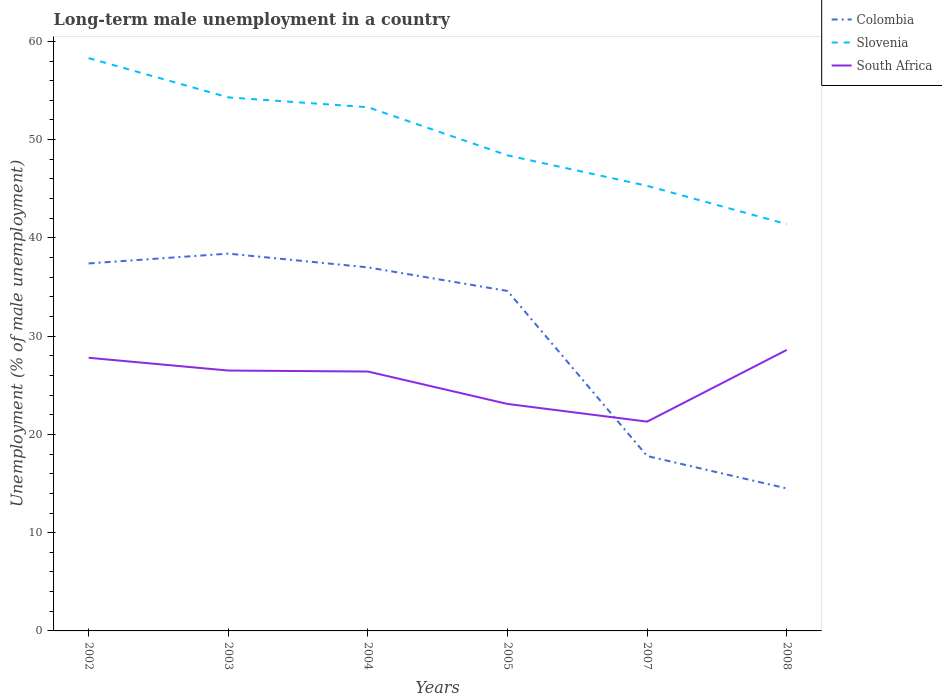Does the line corresponding to Colombia intersect with the line corresponding to Slovenia?
Offer a terse response. No. Is the number of lines equal to the number of legend labels?
Ensure brevity in your answer.  Yes. Across all years, what is the maximum percentage of long-term unemployed male population in Slovenia?
Offer a terse response. 41.4. What is the total percentage of long-term unemployed male population in Slovenia in the graph?
Offer a terse response. 12.9. What is the difference between the highest and the second highest percentage of long-term unemployed male population in Colombia?
Provide a short and direct response. 23.9. How many lines are there?
Provide a short and direct response. 3. How many years are there in the graph?
Keep it short and to the point. 6. What is the difference between two consecutive major ticks on the Y-axis?
Offer a terse response. 10. Does the graph contain any zero values?
Offer a very short reply. No. Does the graph contain grids?
Make the answer very short. No. Where does the legend appear in the graph?
Provide a succinct answer. Top right. How many legend labels are there?
Make the answer very short. 3. How are the legend labels stacked?
Your response must be concise. Vertical. What is the title of the graph?
Give a very brief answer. Long-term male unemployment in a country. Does "Canada" appear as one of the legend labels in the graph?
Give a very brief answer. No. What is the label or title of the Y-axis?
Give a very brief answer. Unemployment (% of male unemployment). What is the Unemployment (% of male unemployment) of Colombia in 2002?
Your answer should be very brief. 37.4. What is the Unemployment (% of male unemployment) in Slovenia in 2002?
Offer a very short reply. 58.3. What is the Unemployment (% of male unemployment) of South Africa in 2002?
Ensure brevity in your answer.  27.8. What is the Unemployment (% of male unemployment) in Colombia in 2003?
Give a very brief answer. 38.4. What is the Unemployment (% of male unemployment) of Slovenia in 2003?
Offer a terse response. 54.3. What is the Unemployment (% of male unemployment) of South Africa in 2003?
Provide a short and direct response. 26.5. What is the Unemployment (% of male unemployment) of Slovenia in 2004?
Your answer should be compact. 53.3. What is the Unemployment (% of male unemployment) of South Africa in 2004?
Make the answer very short. 26.4. What is the Unemployment (% of male unemployment) in Colombia in 2005?
Provide a short and direct response. 34.6. What is the Unemployment (% of male unemployment) of Slovenia in 2005?
Offer a terse response. 48.4. What is the Unemployment (% of male unemployment) of South Africa in 2005?
Provide a succinct answer. 23.1. What is the Unemployment (% of male unemployment) in Colombia in 2007?
Give a very brief answer. 17.8. What is the Unemployment (% of male unemployment) in Slovenia in 2007?
Your answer should be very brief. 45.3. What is the Unemployment (% of male unemployment) in South Africa in 2007?
Provide a short and direct response. 21.3. What is the Unemployment (% of male unemployment) in Slovenia in 2008?
Your answer should be compact. 41.4. What is the Unemployment (% of male unemployment) in South Africa in 2008?
Provide a short and direct response. 28.6. Across all years, what is the maximum Unemployment (% of male unemployment) in Colombia?
Offer a terse response. 38.4. Across all years, what is the maximum Unemployment (% of male unemployment) in Slovenia?
Make the answer very short. 58.3. Across all years, what is the maximum Unemployment (% of male unemployment) of South Africa?
Ensure brevity in your answer.  28.6. Across all years, what is the minimum Unemployment (% of male unemployment) in Colombia?
Provide a succinct answer. 14.5. Across all years, what is the minimum Unemployment (% of male unemployment) of Slovenia?
Make the answer very short. 41.4. Across all years, what is the minimum Unemployment (% of male unemployment) of South Africa?
Provide a short and direct response. 21.3. What is the total Unemployment (% of male unemployment) in Colombia in the graph?
Offer a terse response. 179.7. What is the total Unemployment (% of male unemployment) in Slovenia in the graph?
Make the answer very short. 301. What is the total Unemployment (% of male unemployment) in South Africa in the graph?
Your answer should be very brief. 153.7. What is the difference between the Unemployment (% of male unemployment) of Colombia in 2002 and that in 2003?
Give a very brief answer. -1. What is the difference between the Unemployment (% of male unemployment) of South Africa in 2002 and that in 2003?
Your answer should be very brief. 1.3. What is the difference between the Unemployment (% of male unemployment) in Colombia in 2002 and that in 2004?
Ensure brevity in your answer.  0.4. What is the difference between the Unemployment (% of male unemployment) of South Africa in 2002 and that in 2004?
Make the answer very short. 1.4. What is the difference between the Unemployment (% of male unemployment) in Colombia in 2002 and that in 2005?
Provide a succinct answer. 2.8. What is the difference between the Unemployment (% of male unemployment) of Slovenia in 2002 and that in 2005?
Provide a short and direct response. 9.9. What is the difference between the Unemployment (% of male unemployment) of South Africa in 2002 and that in 2005?
Your answer should be very brief. 4.7. What is the difference between the Unemployment (% of male unemployment) in Colombia in 2002 and that in 2007?
Provide a succinct answer. 19.6. What is the difference between the Unemployment (% of male unemployment) in South Africa in 2002 and that in 2007?
Your answer should be very brief. 6.5. What is the difference between the Unemployment (% of male unemployment) in Colombia in 2002 and that in 2008?
Offer a terse response. 22.9. What is the difference between the Unemployment (% of male unemployment) of Slovenia in 2002 and that in 2008?
Give a very brief answer. 16.9. What is the difference between the Unemployment (% of male unemployment) in South Africa in 2003 and that in 2004?
Make the answer very short. 0.1. What is the difference between the Unemployment (% of male unemployment) in Colombia in 2003 and that in 2005?
Give a very brief answer. 3.8. What is the difference between the Unemployment (% of male unemployment) of Slovenia in 2003 and that in 2005?
Ensure brevity in your answer.  5.9. What is the difference between the Unemployment (% of male unemployment) in South Africa in 2003 and that in 2005?
Ensure brevity in your answer.  3.4. What is the difference between the Unemployment (% of male unemployment) in Colombia in 2003 and that in 2007?
Offer a terse response. 20.6. What is the difference between the Unemployment (% of male unemployment) of Colombia in 2003 and that in 2008?
Provide a succinct answer. 23.9. What is the difference between the Unemployment (% of male unemployment) in Slovenia in 2003 and that in 2008?
Keep it short and to the point. 12.9. What is the difference between the Unemployment (% of male unemployment) of South Africa in 2003 and that in 2008?
Keep it short and to the point. -2.1. What is the difference between the Unemployment (% of male unemployment) of Slovenia in 2004 and that in 2005?
Keep it short and to the point. 4.9. What is the difference between the Unemployment (% of male unemployment) in South Africa in 2004 and that in 2005?
Offer a terse response. 3.3. What is the difference between the Unemployment (% of male unemployment) in Colombia in 2004 and that in 2007?
Provide a short and direct response. 19.2. What is the difference between the Unemployment (% of male unemployment) of Colombia in 2004 and that in 2008?
Your answer should be very brief. 22.5. What is the difference between the Unemployment (% of male unemployment) in Slovenia in 2004 and that in 2008?
Your answer should be very brief. 11.9. What is the difference between the Unemployment (% of male unemployment) in South Africa in 2004 and that in 2008?
Make the answer very short. -2.2. What is the difference between the Unemployment (% of male unemployment) of Colombia in 2005 and that in 2007?
Ensure brevity in your answer.  16.8. What is the difference between the Unemployment (% of male unemployment) in Slovenia in 2005 and that in 2007?
Provide a succinct answer. 3.1. What is the difference between the Unemployment (% of male unemployment) in Colombia in 2005 and that in 2008?
Make the answer very short. 20.1. What is the difference between the Unemployment (% of male unemployment) of Slovenia in 2005 and that in 2008?
Your answer should be compact. 7. What is the difference between the Unemployment (% of male unemployment) of South Africa in 2005 and that in 2008?
Your answer should be compact. -5.5. What is the difference between the Unemployment (% of male unemployment) of Colombia in 2002 and the Unemployment (% of male unemployment) of Slovenia in 2003?
Make the answer very short. -16.9. What is the difference between the Unemployment (% of male unemployment) in Colombia in 2002 and the Unemployment (% of male unemployment) in South Africa in 2003?
Give a very brief answer. 10.9. What is the difference between the Unemployment (% of male unemployment) in Slovenia in 2002 and the Unemployment (% of male unemployment) in South Africa in 2003?
Ensure brevity in your answer.  31.8. What is the difference between the Unemployment (% of male unemployment) of Colombia in 2002 and the Unemployment (% of male unemployment) of Slovenia in 2004?
Offer a very short reply. -15.9. What is the difference between the Unemployment (% of male unemployment) of Colombia in 2002 and the Unemployment (% of male unemployment) of South Africa in 2004?
Give a very brief answer. 11. What is the difference between the Unemployment (% of male unemployment) of Slovenia in 2002 and the Unemployment (% of male unemployment) of South Africa in 2004?
Offer a very short reply. 31.9. What is the difference between the Unemployment (% of male unemployment) of Colombia in 2002 and the Unemployment (% of male unemployment) of Slovenia in 2005?
Ensure brevity in your answer.  -11. What is the difference between the Unemployment (% of male unemployment) of Colombia in 2002 and the Unemployment (% of male unemployment) of South Africa in 2005?
Your answer should be compact. 14.3. What is the difference between the Unemployment (% of male unemployment) in Slovenia in 2002 and the Unemployment (% of male unemployment) in South Africa in 2005?
Ensure brevity in your answer.  35.2. What is the difference between the Unemployment (% of male unemployment) of Colombia in 2002 and the Unemployment (% of male unemployment) of South Africa in 2007?
Make the answer very short. 16.1. What is the difference between the Unemployment (% of male unemployment) of Slovenia in 2002 and the Unemployment (% of male unemployment) of South Africa in 2007?
Make the answer very short. 37. What is the difference between the Unemployment (% of male unemployment) of Slovenia in 2002 and the Unemployment (% of male unemployment) of South Africa in 2008?
Offer a terse response. 29.7. What is the difference between the Unemployment (% of male unemployment) in Colombia in 2003 and the Unemployment (% of male unemployment) in Slovenia in 2004?
Ensure brevity in your answer.  -14.9. What is the difference between the Unemployment (% of male unemployment) in Colombia in 2003 and the Unemployment (% of male unemployment) in South Africa in 2004?
Provide a short and direct response. 12. What is the difference between the Unemployment (% of male unemployment) of Slovenia in 2003 and the Unemployment (% of male unemployment) of South Africa in 2004?
Your response must be concise. 27.9. What is the difference between the Unemployment (% of male unemployment) of Colombia in 2003 and the Unemployment (% of male unemployment) of Slovenia in 2005?
Keep it short and to the point. -10. What is the difference between the Unemployment (% of male unemployment) of Slovenia in 2003 and the Unemployment (% of male unemployment) of South Africa in 2005?
Your response must be concise. 31.2. What is the difference between the Unemployment (% of male unemployment) in Colombia in 2003 and the Unemployment (% of male unemployment) in South Africa in 2007?
Keep it short and to the point. 17.1. What is the difference between the Unemployment (% of male unemployment) of Colombia in 2003 and the Unemployment (% of male unemployment) of Slovenia in 2008?
Give a very brief answer. -3. What is the difference between the Unemployment (% of male unemployment) in Slovenia in 2003 and the Unemployment (% of male unemployment) in South Africa in 2008?
Give a very brief answer. 25.7. What is the difference between the Unemployment (% of male unemployment) in Colombia in 2004 and the Unemployment (% of male unemployment) in Slovenia in 2005?
Offer a very short reply. -11.4. What is the difference between the Unemployment (% of male unemployment) in Colombia in 2004 and the Unemployment (% of male unemployment) in South Africa in 2005?
Offer a very short reply. 13.9. What is the difference between the Unemployment (% of male unemployment) of Slovenia in 2004 and the Unemployment (% of male unemployment) of South Africa in 2005?
Offer a very short reply. 30.2. What is the difference between the Unemployment (% of male unemployment) in Colombia in 2004 and the Unemployment (% of male unemployment) in South Africa in 2007?
Make the answer very short. 15.7. What is the difference between the Unemployment (% of male unemployment) of Slovenia in 2004 and the Unemployment (% of male unemployment) of South Africa in 2008?
Your answer should be very brief. 24.7. What is the difference between the Unemployment (% of male unemployment) of Colombia in 2005 and the Unemployment (% of male unemployment) of South Africa in 2007?
Offer a very short reply. 13.3. What is the difference between the Unemployment (% of male unemployment) in Slovenia in 2005 and the Unemployment (% of male unemployment) in South Africa in 2007?
Provide a succinct answer. 27.1. What is the difference between the Unemployment (% of male unemployment) of Colombia in 2005 and the Unemployment (% of male unemployment) of Slovenia in 2008?
Your answer should be very brief. -6.8. What is the difference between the Unemployment (% of male unemployment) in Slovenia in 2005 and the Unemployment (% of male unemployment) in South Africa in 2008?
Give a very brief answer. 19.8. What is the difference between the Unemployment (% of male unemployment) in Colombia in 2007 and the Unemployment (% of male unemployment) in Slovenia in 2008?
Provide a short and direct response. -23.6. What is the difference between the Unemployment (% of male unemployment) of Slovenia in 2007 and the Unemployment (% of male unemployment) of South Africa in 2008?
Offer a very short reply. 16.7. What is the average Unemployment (% of male unemployment) in Colombia per year?
Offer a very short reply. 29.95. What is the average Unemployment (% of male unemployment) in Slovenia per year?
Your response must be concise. 50.17. What is the average Unemployment (% of male unemployment) of South Africa per year?
Your answer should be very brief. 25.62. In the year 2002, what is the difference between the Unemployment (% of male unemployment) in Colombia and Unemployment (% of male unemployment) in Slovenia?
Your answer should be compact. -20.9. In the year 2002, what is the difference between the Unemployment (% of male unemployment) of Colombia and Unemployment (% of male unemployment) of South Africa?
Provide a succinct answer. 9.6. In the year 2002, what is the difference between the Unemployment (% of male unemployment) in Slovenia and Unemployment (% of male unemployment) in South Africa?
Provide a succinct answer. 30.5. In the year 2003, what is the difference between the Unemployment (% of male unemployment) of Colombia and Unemployment (% of male unemployment) of Slovenia?
Make the answer very short. -15.9. In the year 2003, what is the difference between the Unemployment (% of male unemployment) in Slovenia and Unemployment (% of male unemployment) in South Africa?
Keep it short and to the point. 27.8. In the year 2004, what is the difference between the Unemployment (% of male unemployment) in Colombia and Unemployment (% of male unemployment) in Slovenia?
Provide a short and direct response. -16.3. In the year 2004, what is the difference between the Unemployment (% of male unemployment) of Slovenia and Unemployment (% of male unemployment) of South Africa?
Make the answer very short. 26.9. In the year 2005, what is the difference between the Unemployment (% of male unemployment) in Colombia and Unemployment (% of male unemployment) in Slovenia?
Keep it short and to the point. -13.8. In the year 2005, what is the difference between the Unemployment (% of male unemployment) of Slovenia and Unemployment (% of male unemployment) of South Africa?
Provide a succinct answer. 25.3. In the year 2007, what is the difference between the Unemployment (% of male unemployment) of Colombia and Unemployment (% of male unemployment) of Slovenia?
Provide a succinct answer. -27.5. In the year 2007, what is the difference between the Unemployment (% of male unemployment) of Slovenia and Unemployment (% of male unemployment) of South Africa?
Keep it short and to the point. 24. In the year 2008, what is the difference between the Unemployment (% of male unemployment) of Colombia and Unemployment (% of male unemployment) of Slovenia?
Offer a very short reply. -26.9. In the year 2008, what is the difference between the Unemployment (% of male unemployment) in Colombia and Unemployment (% of male unemployment) in South Africa?
Your response must be concise. -14.1. In the year 2008, what is the difference between the Unemployment (% of male unemployment) of Slovenia and Unemployment (% of male unemployment) of South Africa?
Provide a succinct answer. 12.8. What is the ratio of the Unemployment (% of male unemployment) of Colombia in 2002 to that in 2003?
Offer a very short reply. 0.97. What is the ratio of the Unemployment (% of male unemployment) in Slovenia in 2002 to that in 2003?
Ensure brevity in your answer.  1.07. What is the ratio of the Unemployment (% of male unemployment) in South Africa in 2002 to that in 2003?
Give a very brief answer. 1.05. What is the ratio of the Unemployment (% of male unemployment) of Colombia in 2002 to that in 2004?
Your response must be concise. 1.01. What is the ratio of the Unemployment (% of male unemployment) in Slovenia in 2002 to that in 2004?
Your answer should be compact. 1.09. What is the ratio of the Unemployment (% of male unemployment) in South Africa in 2002 to that in 2004?
Ensure brevity in your answer.  1.05. What is the ratio of the Unemployment (% of male unemployment) in Colombia in 2002 to that in 2005?
Your answer should be compact. 1.08. What is the ratio of the Unemployment (% of male unemployment) in Slovenia in 2002 to that in 2005?
Offer a very short reply. 1.2. What is the ratio of the Unemployment (% of male unemployment) in South Africa in 2002 to that in 2005?
Offer a terse response. 1.2. What is the ratio of the Unemployment (% of male unemployment) of Colombia in 2002 to that in 2007?
Your answer should be very brief. 2.1. What is the ratio of the Unemployment (% of male unemployment) of Slovenia in 2002 to that in 2007?
Your answer should be very brief. 1.29. What is the ratio of the Unemployment (% of male unemployment) of South Africa in 2002 to that in 2007?
Your answer should be very brief. 1.31. What is the ratio of the Unemployment (% of male unemployment) in Colombia in 2002 to that in 2008?
Make the answer very short. 2.58. What is the ratio of the Unemployment (% of male unemployment) of Slovenia in 2002 to that in 2008?
Keep it short and to the point. 1.41. What is the ratio of the Unemployment (% of male unemployment) of Colombia in 2003 to that in 2004?
Keep it short and to the point. 1.04. What is the ratio of the Unemployment (% of male unemployment) of Slovenia in 2003 to that in 2004?
Offer a very short reply. 1.02. What is the ratio of the Unemployment (% of male unemployment) of South Africa in 2003 to that in 2004?
Give a very brief answer. 1. What is the ratio of the Unemployment (% of male unemployment) of Colombia in 2003 to that in 2005?
Your response must be concise. 1.11. What is the ratio of the Unemployment (% of male unemployment) of Slovenia in 2003 to that in 2005?
Make the answer very short. 1.12. What is the ratio of the Unemployment (% of male unemployment) in South Africa in 2003 to that in 2005?
Your answer should be compact. 1.15. What is the ratio of the Unemployment (% of male unemployment) of Colombia in 2003 to that in 2007?
Keep it short and to the point. 2.16. What is the ratio of the Unemployment (% of male unemployment) of Slovenia in 2003 to that in 2007?
Keep it short and to the point. 1.2. What is the ratio of the Unemployment (% of male unemployment) in South Africa in 2003 to that in 2007?
Your answer should be compact. 1.24. What is the ratio of the Unemployment (% of male unemployment) of Colombia in 2003 to that in 2008?
Your response must be concise. 2.65. What is the ratio of the Unemployment (% of male unemployment) of Slovenia in 2003 to that in 2008?
Ensure brevity in your answer.  1.31. What is the ratio of the Unemployment (% of male unemployment) in South Africa in 2003 to that in 2008?
Your answer should be very brief. 0.93. What is the ratio of the Unemployment (% of male unemployment) of Colombia in 2004 to that in 2005?
Make the answer very short. 1.07. What is the ratio of the Unemployment (% of male unemployment) of Slovenia in 2004 to that in 2005?
Give a very brief answer. 1.1. What is the ratio of the Unemployment (% of male unemployment) of South Africa in 2004 to that in 2005?
Make the answer very short. 1.14. What is the ratio of the Unemployment (% of male unemployment) of Colombia in 2004 to that in 2007?
Your response must be concise. 2.08. What is the ratio of the Unemployment (% of male unemployment) in Slovenia in 2004 to that in 2007?
Offer a very short reply. 1.18. What is the ratio of the Unemployment (% of male unemployment) of South Africa in 2004 to that in 2007?
Give a very brief answer. 1.24. What is the ratio of the Unemployment (% of male unemployment) of Colombia in 2004 to that in 2008?
Offer a very short reply. 2.55. What is the ratio of the Unemployment (% of male unemployment) in Slovenia in 2004 to that in 2008?
Make the answer very short. 1.29. What is the ratio of the Unemployment (% of male unemployment) in South Africa in 2004 to that in 2008?
Ensure brevity in your answer.  0.92. What is the ratio of the Unemployment (% of male unemployment) in Colombia in 2005 to that in 2007?
Offer a terse response. 1.94. What is the ratio of the Unemployment (% of male unemployment) of Slovenia in 2005 to that in 2007?
Provide a succinct answer. 1.07. What is the ratio of the Unemployment (% of male unemployment) of South Africa in 2005 to that in 2007?
Offer a terse response. 1.08. What is the ratio of the Unemployment (% of male unemployment) in Colombia in 2005 to that in 2008?
Your response must be concise. 2.39. What is the ratio of the Unemployment (% of male unemployment) in Slovenia in 2005 to that in 2008?
Your answer should be compact. 1.17. What is the ratio of the Unemployment (% of male unemployment) of South Africa in 2005 to that in 2008?
Provide a short and direct response. 0.81. What is the ratio of the Unemployment (% of male unemployment) in Colombia in 2007 to that in 2008?
Provide a short and direct response. 1.23. What is the ratio of the Unemployment (% of male unemployment) in Slovenia in 2007 to that in 2008?
Your answer should be very brief. 1.09. What is the ratio of the Unemployment (% of male unemployment) of South Africa in 2007 to that in 2008?
Give a very brief answer. 0.74. What is the difference between the highest and the second highest Unemployment (% of male unemployment) in Colombia?
Ensure brevity in your answer.  1. What is the difference between the highest and the lowest Unemployment (% of male unemployment) in Colombia?
Provide a succinct answer. 23.9. 